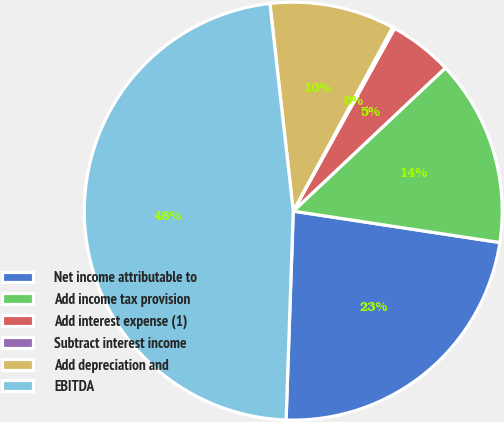Convert chart. <chart><loc_0><loc_0><loc_500><loc_500><pie_chart><fcel>Net income attributable to<fcel>Add income tax provision<fcel>Add interest expense (1)<fcel>Subtract interest income<fcel>Add depreciation and<fcel>EBITDA<nl><fcel>23.14%<fcel>14.42%<fcel>4.92%<fcel>0.17%<fcel>9.67%<fcel>47.66%<nl></chart> 